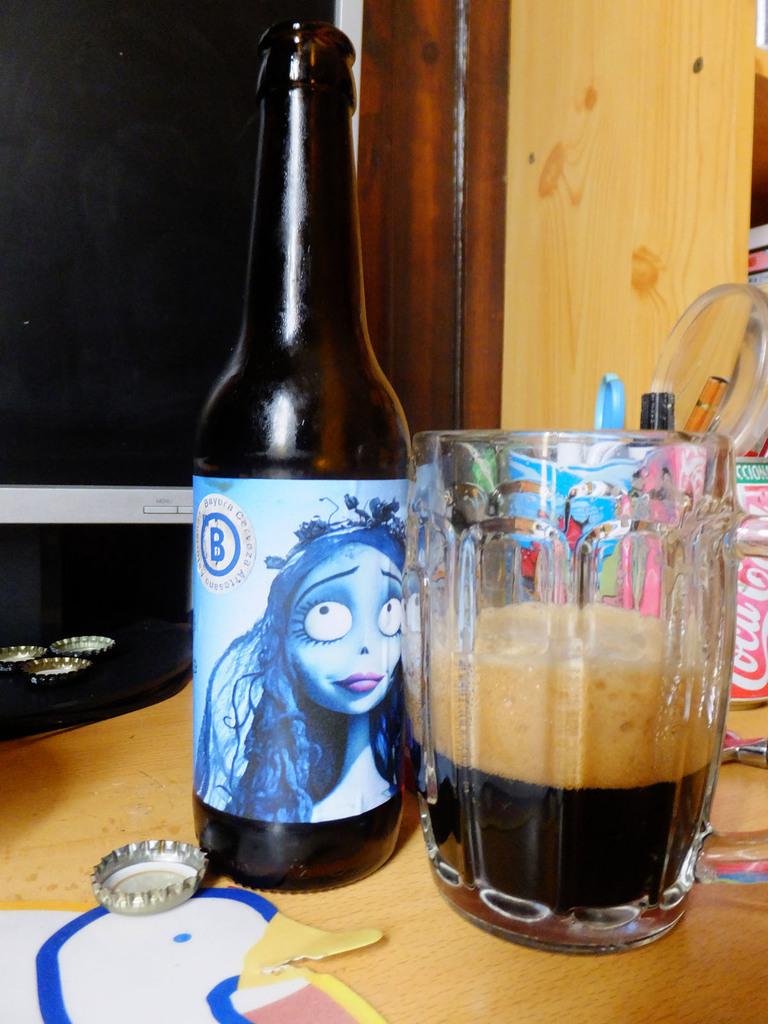What letter is on the bottle?
Provide a short and direct response. B. What soft drink is behind the mug?
Make the answer very short. Coca cola. 